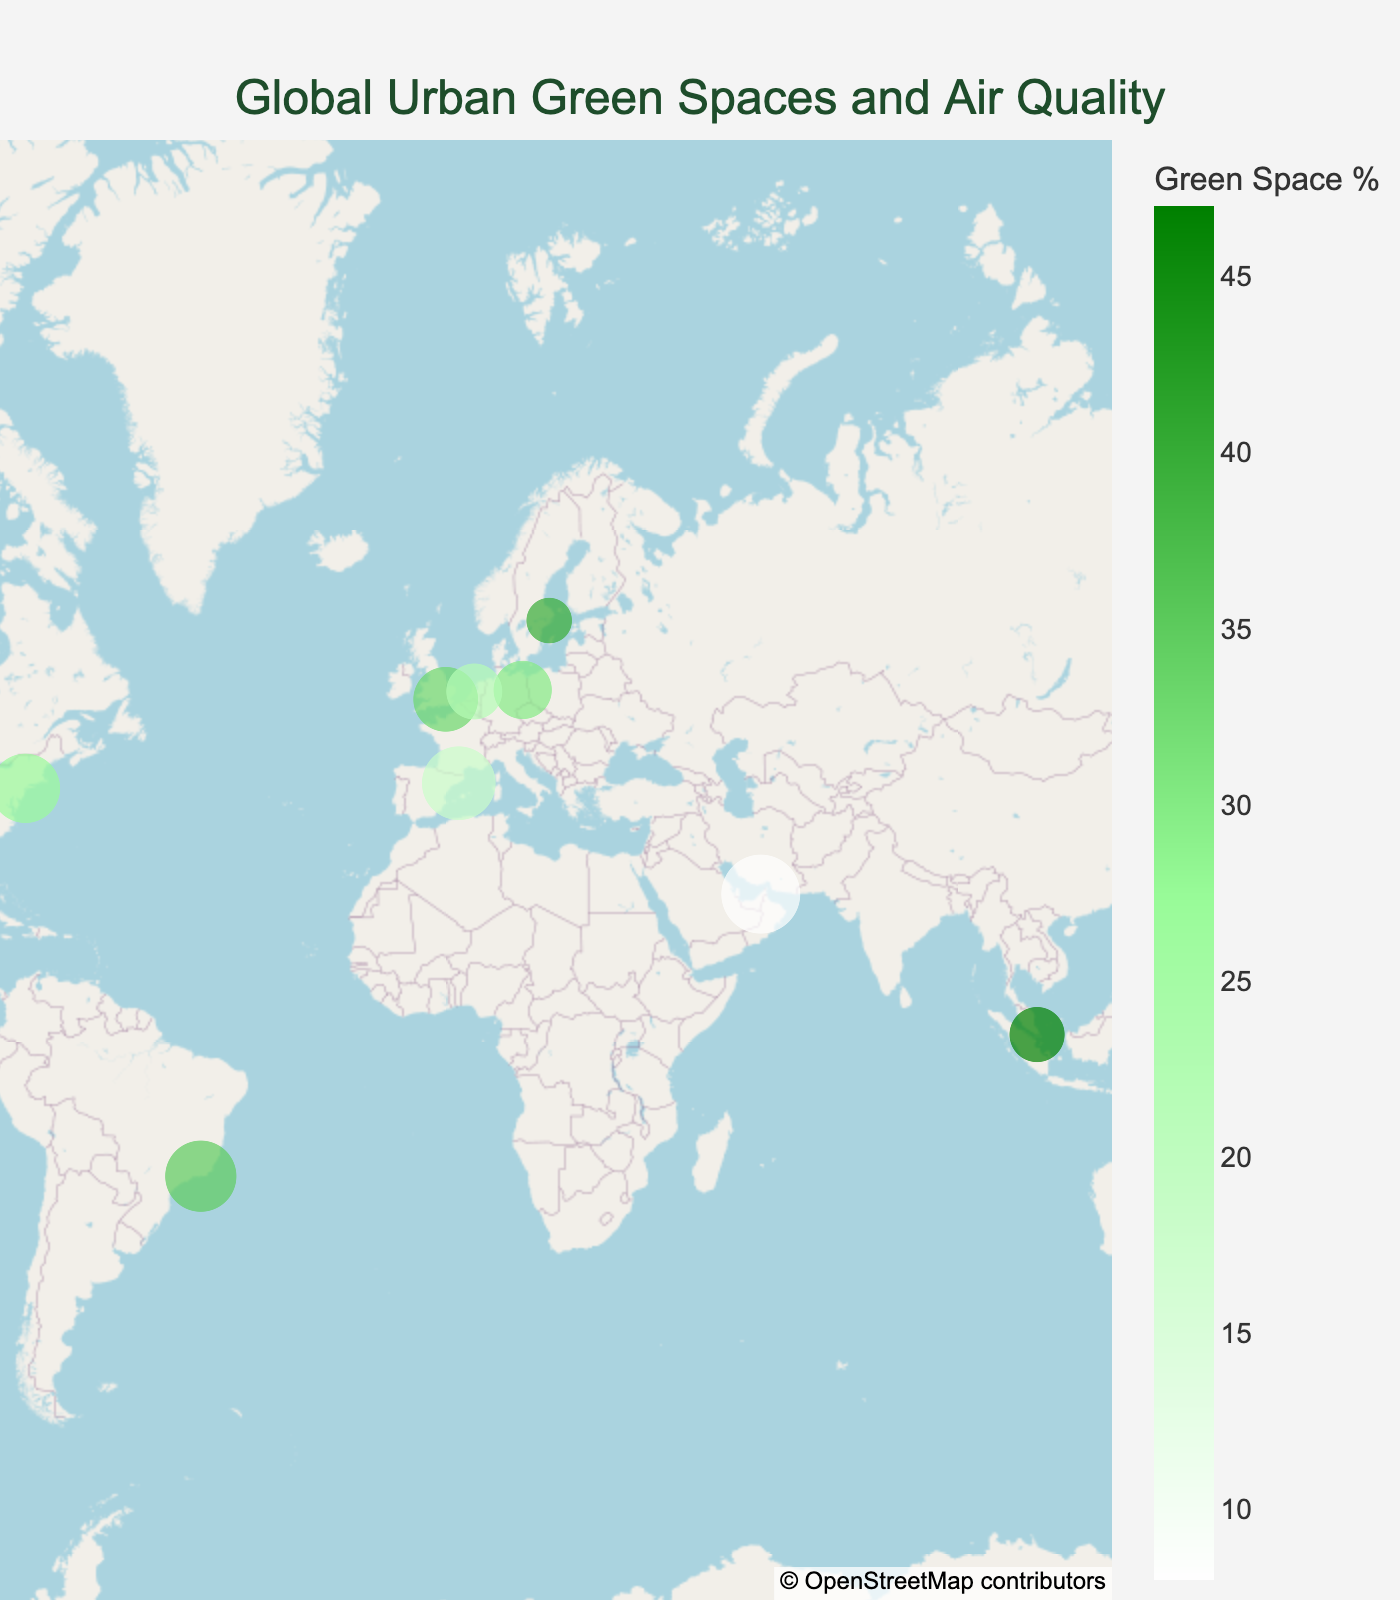What is the title of the plot? The title is displayed at the top of the figure. It is in a larger font and conveys the main topic of the visualization.
Answer: "Global Urban Green Spaces and Air Quality" Which city has the highest percentage of green space? Look for the city with the darkest green color, as the color scale indicates that darker green corresponds to a higher percentage of green spaces.
Answer: Singapore What is the Air Quality Index (AQI) of Melbourne? Identify the data point corresponding to Melbourne and observe the AQI value associated with it.
Answer: 30 How many cities in the plot have a green space percentage greater than 35%? Count all the cities that have a green space value greater than 35%.
Answer: 4 Which city has the worst air quality, and what is its AQI? Find the city with the largest circle, as the size of the circles represents the AQI. The largest circle corresponds to the highest AQI value.
Answer: Mexico City, 80 Which city has the largest green space percentage difference compared to New York? Calculate the difference in green space percentages between New York and every other city, then identify the city with the maximum difference.
Answer: Singapore Do cities with higher green space percentages generally have lower AQI values? Observe the trend by comparing the color intensity (green space percentage) with the size of the circles (AQI) in the plot.
Answer: Generally, yes What is the latitude of the city with the second highest green space percentage? Identify the city with the second darkest shade of green, and note its latitude from the hover data.
Answer: Stockholm Which countries have more than one city included in the plot? Check the "Country" data for repeated entries.
Answer: None 